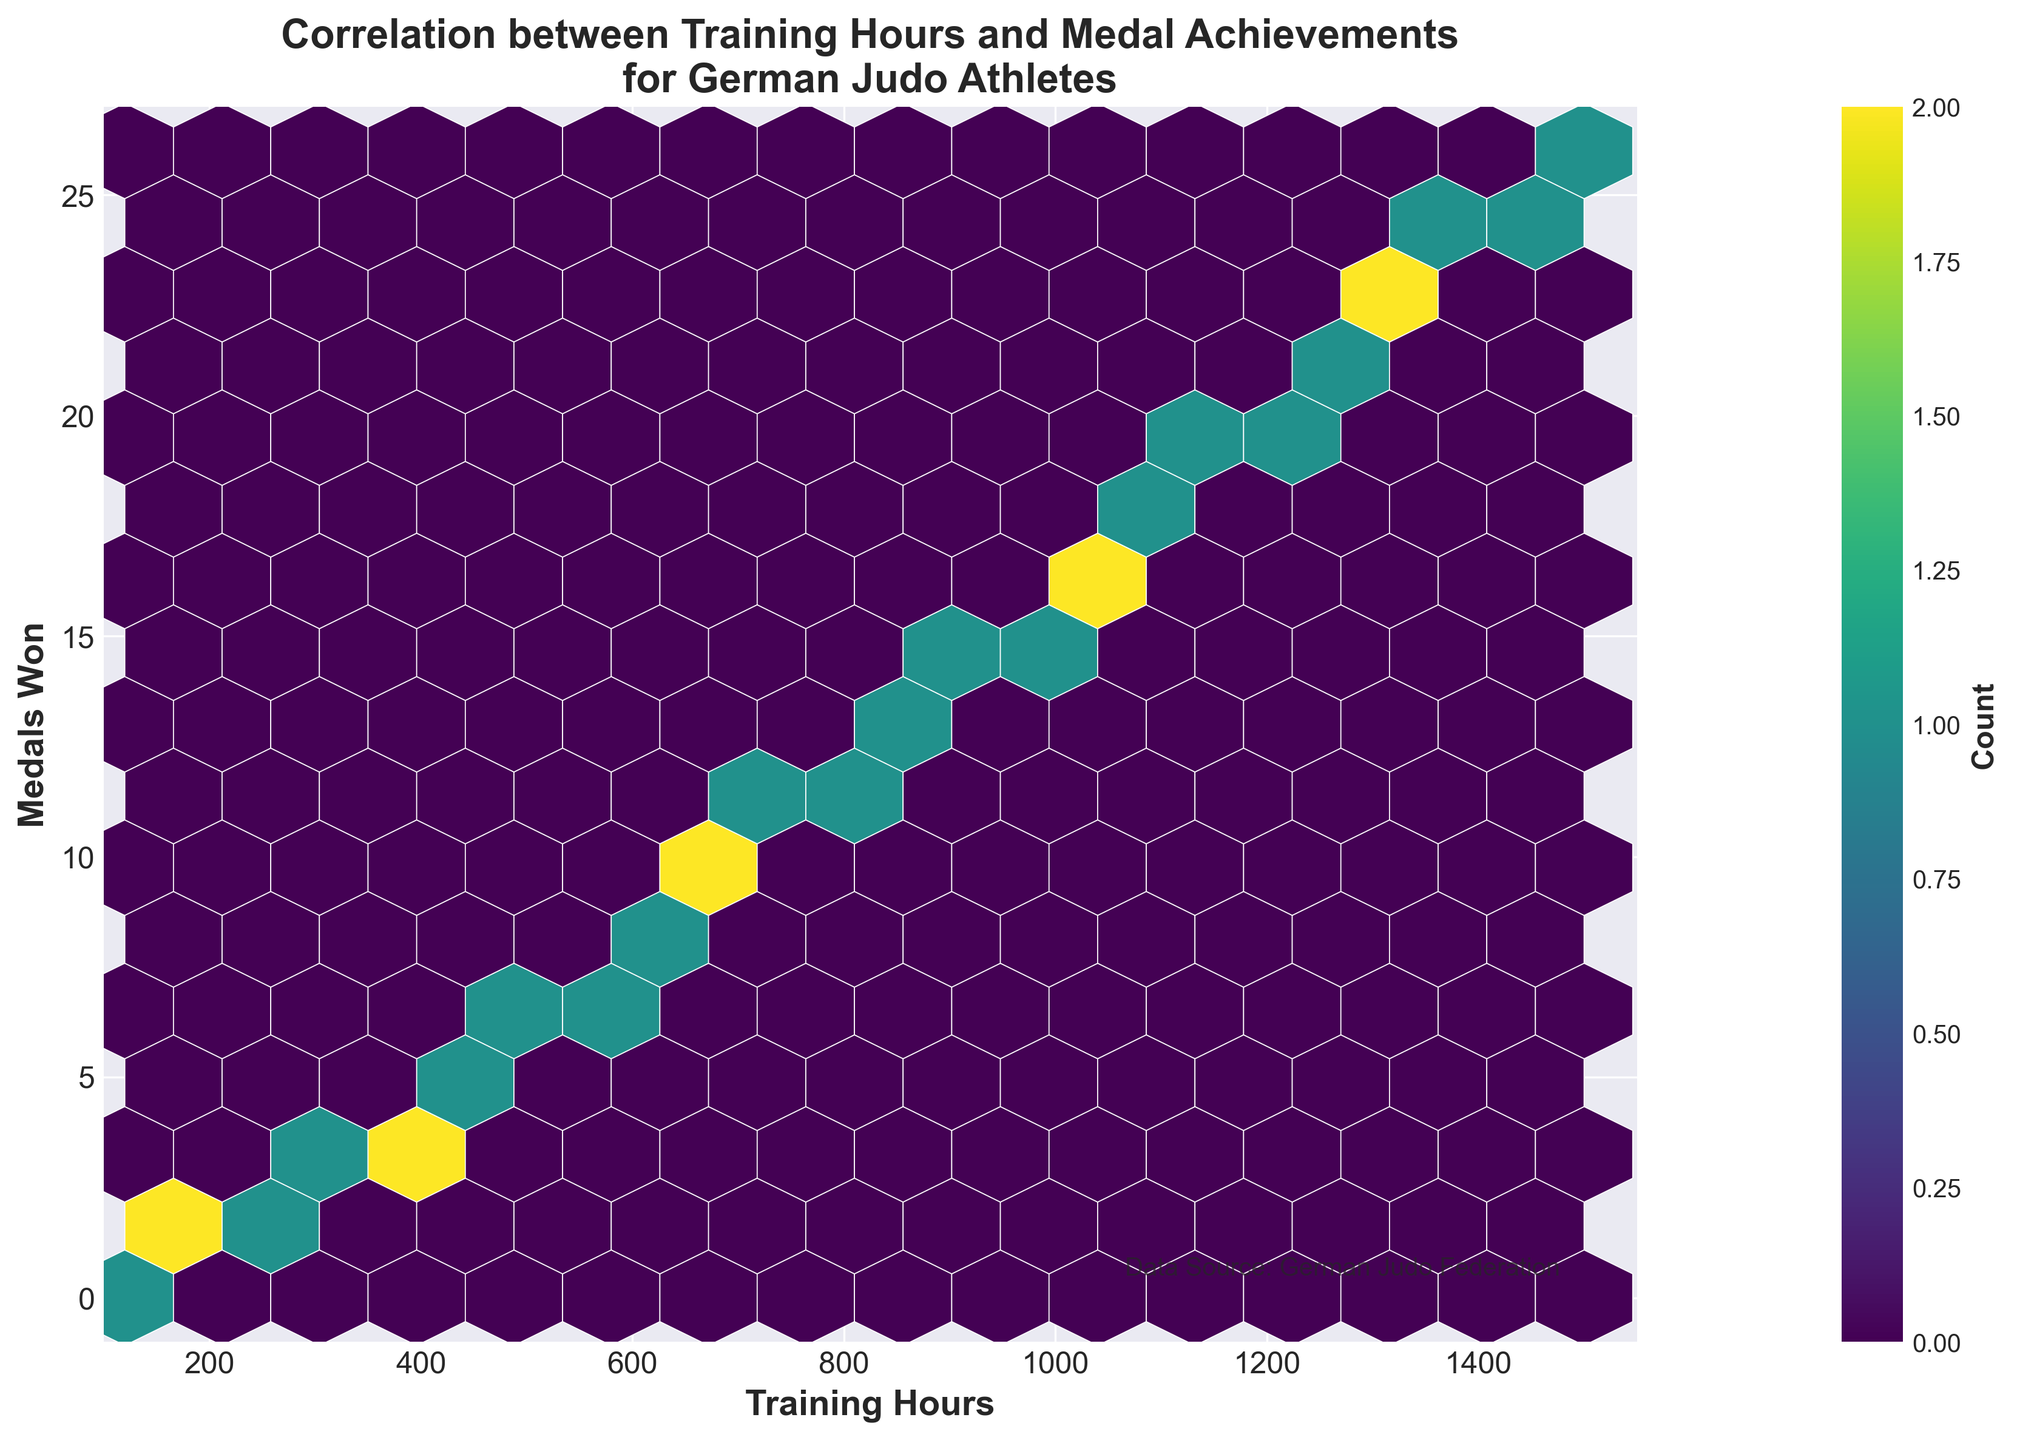What is the title of the figure? The title is located at the top of the plot in a bold, larger font.
Answer: Correlation between Training Hours and Medal Achievements for German Judo Athletes What are the labels of the x-axis and y-axis? The x-axis label is on the horizontal axis and the y-axis label is on the vertical axis.
Answer: Training Hours (x-axis), Medals Won (y-axis) What is the color of the hexagons with the highest count? The hexbin plot uses a color map where higher counts are represented by more intense colors. The highest count is likely represented by the darkest color on the viridis scale.
Answer: Dark purple/blue How many hexagons represent exactly one data point? The color bar shows how different colors correspond to different counts. Locate the color corresponding to 1 on the color bar and count the hexagons with that color.
Answer: 1 At what training hours range do we see the densest clustering of data points? By observing the plot, identify where the concentration of hexagons is the highest. This typically appears as the darkest color locally on the plot.
Answer: 1000-1500 training hours Is there a clear positive correlation between training hours and medals won? Determine if the hexagons follow a general upward trend from left to right.
Answer: Yes Approximately how many medals are won at 800 training hours? Locate the x-coordinate of 800 and observe the corresponding y-coordinate value, noting the color of the hexagon as well.
Answer: Around 12 medals Is the relationship between training hours and medals linear or nonlinear? Examine if the trend of hexagons forms a straight line or curves.
Answer: Linear What is the rate of medals won per 100 training hours between 500 and 1000 hours? Calculate the difference in medals and training hours between these points and find the ratio.
Answer: (16 - 6) / (1000 - 500) = 10 / 500 = 2 medals per 100 hours By examining the hexbin plot, what training hours correspond to winning the highest number of medals? Identify the highest y-coordinate value and its corresponding x-coordinate.
Answer: 1500 training hours 